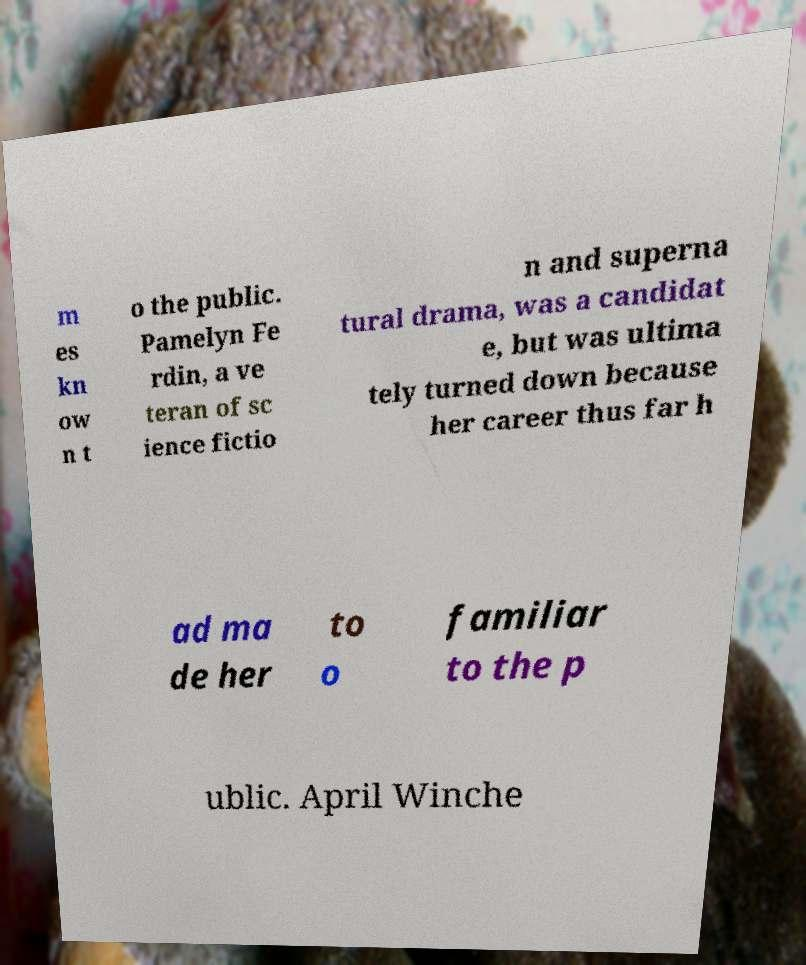For documentation purposes, I need the text within this image transcribed. Could you provide that? m es kn ow n t o the public. Pamelyn Fe rdin, a ve teran of sc ience fictio n and superna tural drama, was a candidat e, but was ultima tely turned down because her career thus far h ad ma de her to o familiar to the p ublic. April Winche 